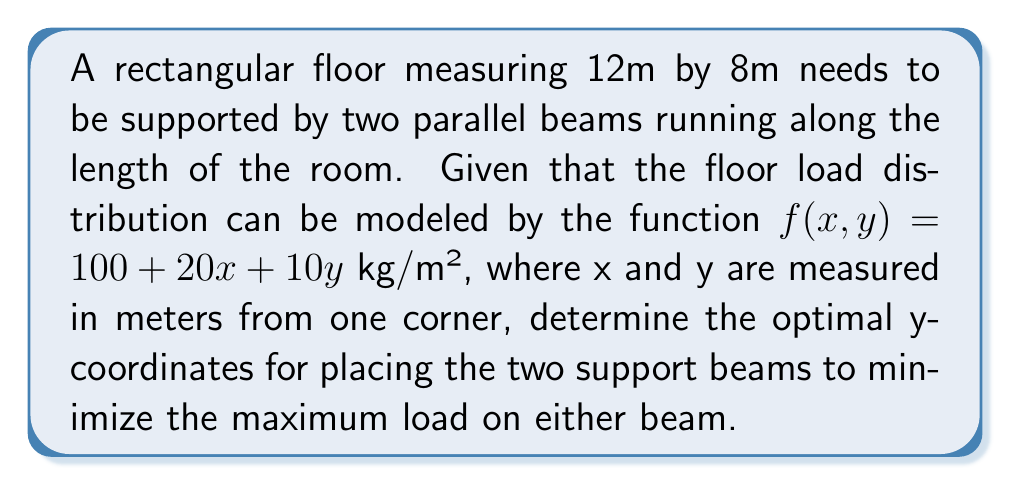Solve this math problem. Let's approach this step-by-step:

1) First, we need to find the total load on the floor:
   $$L_{total} = \int_0^8 \int_0^{12} (100 + 20x + 10y) \, dx \, dy$$

2) Evaluating this integral:
   $$L_{total} = 8 \cdot 12 \cdot 100 + 8 \cdot \frac{12^2}{2} \cdot 20 + \frac{8^2}{2} \cdot 12 \cdot 10 = 17,280 \text{ kg}$$

3) Now, let's consider the load distribution along the y-axis:
   $$g(y) = \int_0^{12} (100 + 20x + 10y) \, dx = 1200 + 1440 + 120y$$

4) To minimize the maximum load on either beam, we need to place the beams so that they each support half of the total load. Let's call the y-coordinates of the beams $y_1$ and $y_2$.

5) We want:
   $$\int_0^{y_1} g(y) \, dy = \int_{y_2}^8 g(y) \, dy = \frac{L_{total}}{2} = 8,640 \text{ kg}$$

6) This leads to the equation:
   $$\int_0^{y_1} (1200 + 1440 + 120y) \, dy = 8,640$$

7) Solving this:
   $$[1200y + 1440y + 60y^2]_0^{y_1} = 8,640$$
   $$2640y_1 + 60y_1^2 = 8,640$$
   $$60y_1^2 + 2640y_1 - 8,640 = 0$$

8) This is a quadratic equation. Solving it:
   $$y_1 = \frac{-2640 + \sqrt{2640^2 + 4 \cdot 60 \cdot 8,640}}{2 \cdot 60} \approx 2.36 \text{ m}$$

9) Due to symmetry, $y_2 = 8 - y_1 \approx 5.64 \text{ m}$
Answer: $y_1 \approx 2.36 \text{ m}$, $y_2 \approx 5.64 \text{ m}$ 